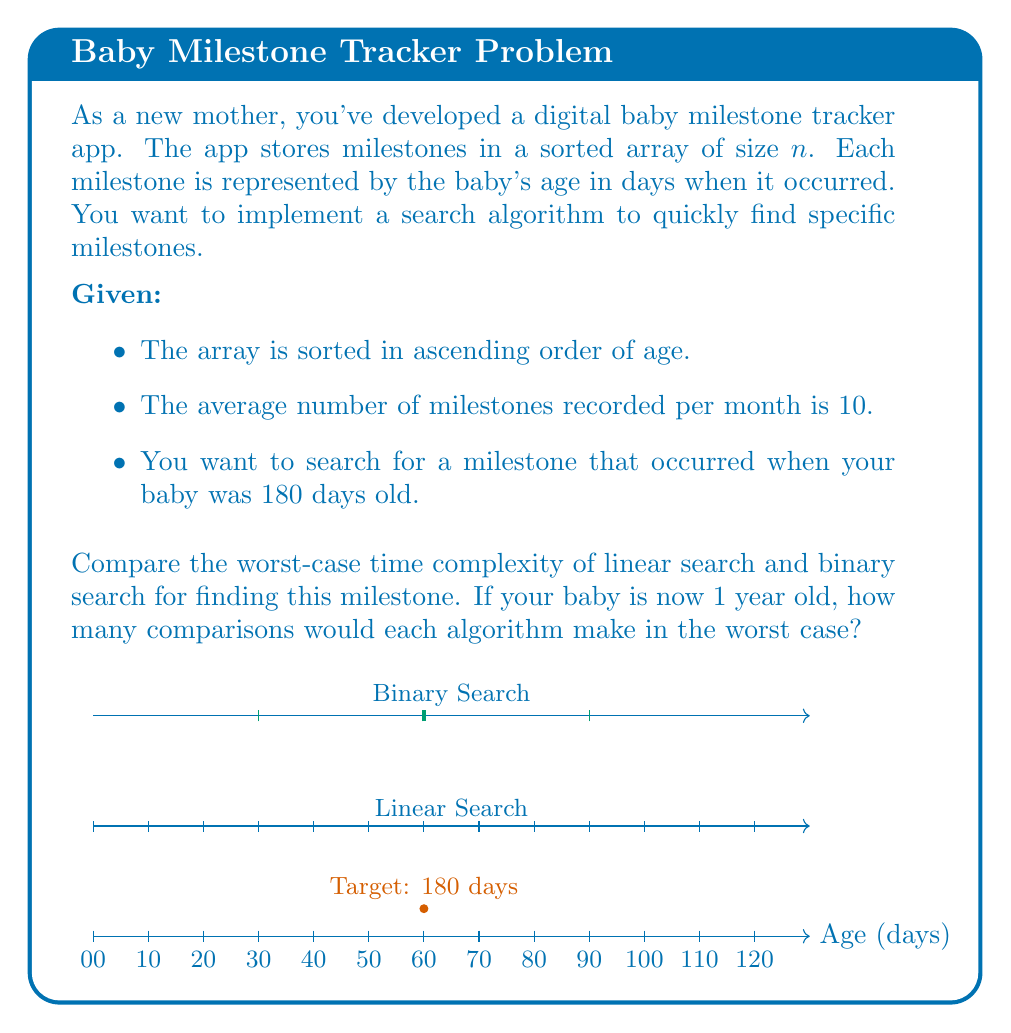Can you answer this question? Let's approach this step-by-step:

1) First, calculate the total number of milestones in 1 year:
   $$ \text{Milestones} = 10 \text{ milestones/month} \times 12 \text{ months} = 120 \text{ milestones} $$

2) Linear Search:
   - Worst-case scenario: The target is at the end of the array or not present.
   - Time complexity: $O(n)$, where $n$ is the number of elements.
   - Worst-case comparisons: 120

3) Binary Search:
   - Requires a sorted array, which we have.
   - Time complexity: $O(\log_2 n)$
   - Worst-case comparisons: $\lfloor \log_2 120 \rfloor + 1$

4) Calculate Binary Search comparisons:
   $$ \lfloor \log_2 120 \rfloor + 1 = \lfloor 6.91 \rfloor + 1 = 6 + 1 = 7 $$

5) Compare:
   - Linear Search: 120 comparisons
   - Binary Search: 7 comparisons

Binary Search is significantly more efficient in this case, requiring only 7 comparisons compared to 120 for Linear Search in the worst case.
Answer: Linear Search: 120 comparisons; Binary Search: 7 comparisons 